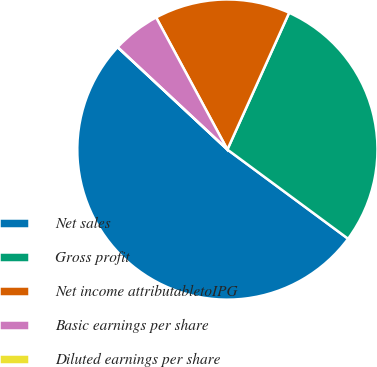<chart> <loc_0><loc_0><loc_500><loc_500><pie_chart><fcel>Net sales<fcel>Gross profit<fcel>Net income attributabletoIPG<fcel>Basic earnings per share<fcel>Diluted earnings per share<nl><fcel>51.82%<fcel>28.38%<fcel>14.62%<fcel>5.18%<fcel>0.0%<nl></chart> 